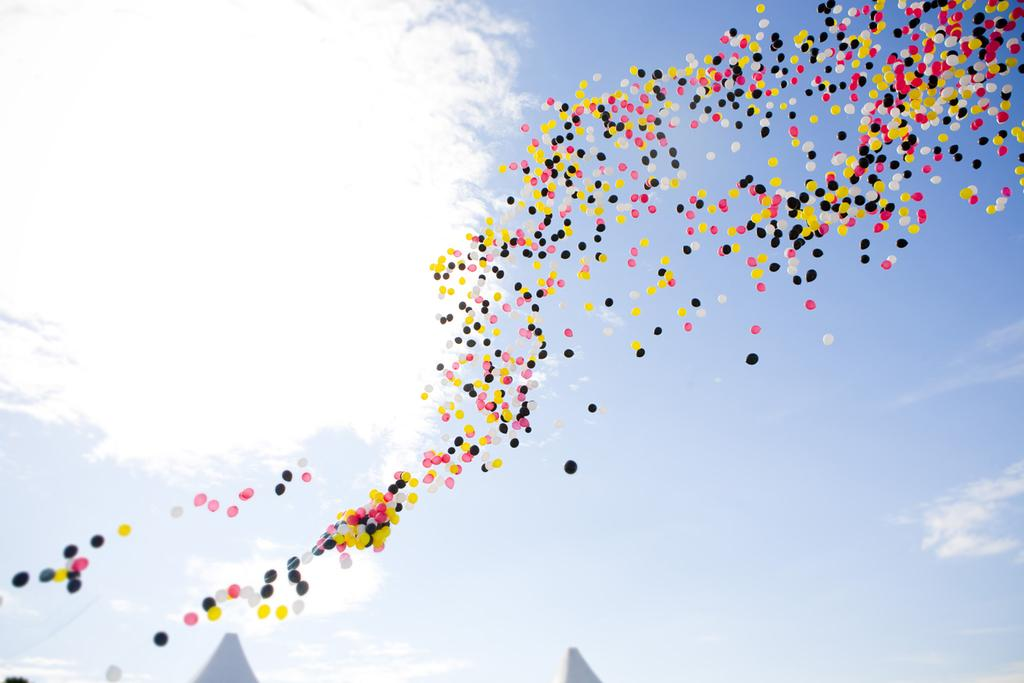What objects are present in the image? There are balloons in the image. What can be seen in the sky in the background of the image? There are clouds visible in the sky in the background of the image. How many cherries are hanging from the balloons in the image? There are no cherries present in the image, as it only features balloons and clouds in the sky. Is there a maid visible in the image? There is no maid present in the image. 